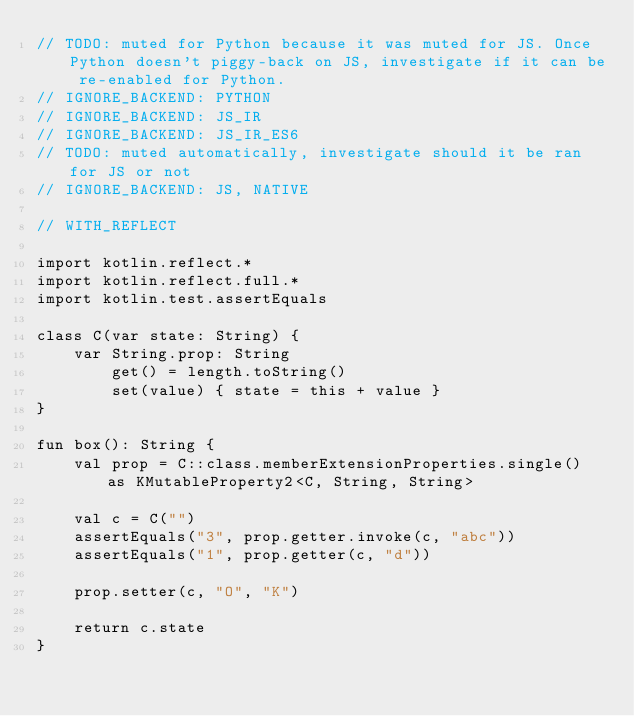Convert code to text. <code><loc_0><loc_0><loc_500><loc_500><_Kotlin_>// TODO: muted for Python because it was muted for JS. Once Python doesn't piggy-back on JS, investigate if it can be re-enabled for Python.
// IGNORE_BACKEND: PYTHON
// IGNORE_BACKEND: JS_IR
// IGNORE_BACKEND: JS_IR_ES6
// TODO: muted automatically, investigate should it be ran for JS or not
// IGNORE_BACKEND: JS, NATIVE

// WITH_REFLECT

import kotlin.reflect.*
import kotlin.reflect.full.*
import kotlin.test.assertEquals

class C(var state: String) {
    var String.prop: String
        get() = length.toString()
        set(value) { state = this + value }
}

fun box(): String {
    val prop = C::class.memberExtensionProperties.single() as KMutableProperty2<C, String, String>

    val c = C("")
    assertEquals("3", prop.getter.invoke(c, "abc"))
    assertEquals("1", prop.getter(c, "d"))

    prop.setter(c, "O", "K")

    return c.state
}
</code> 